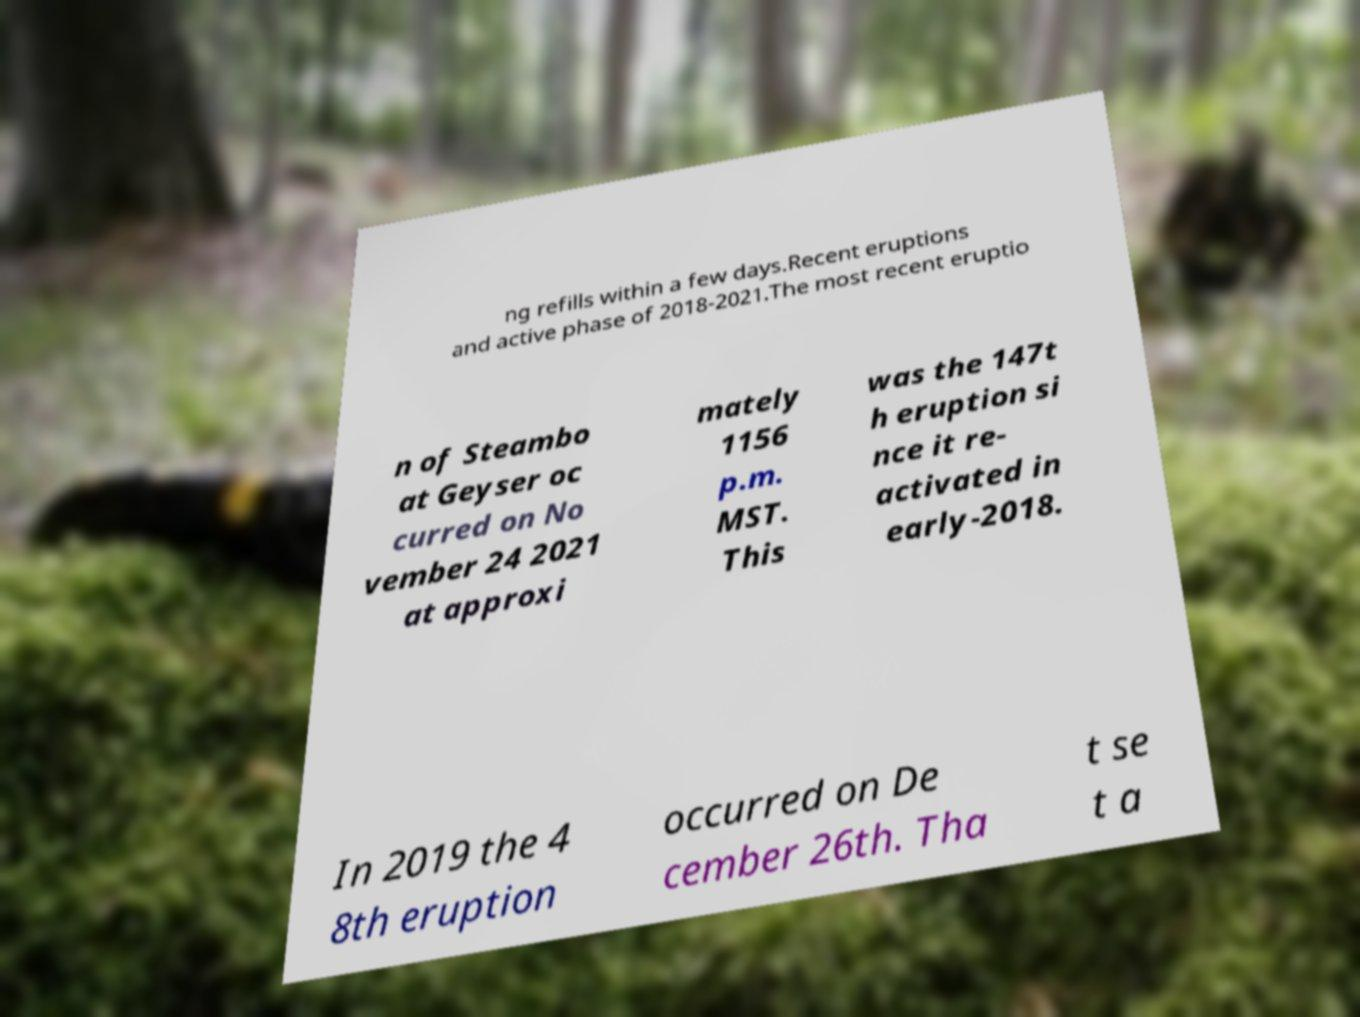What messages or text are displayed in this image? I need them in a readable, typed format. ng refills within a few days.Recent eruptions and active phase of 2018-2021.The most recent eruptio n of Steambo at Geyser oc curred on No vember 24 2021 at approxi mately 1156 p.m. MST. This was the 147t h eruption si nce it re- activated in early-2018. In 2019 the 4 8th eruption occurred on De cember 26th. Tha t se t a 